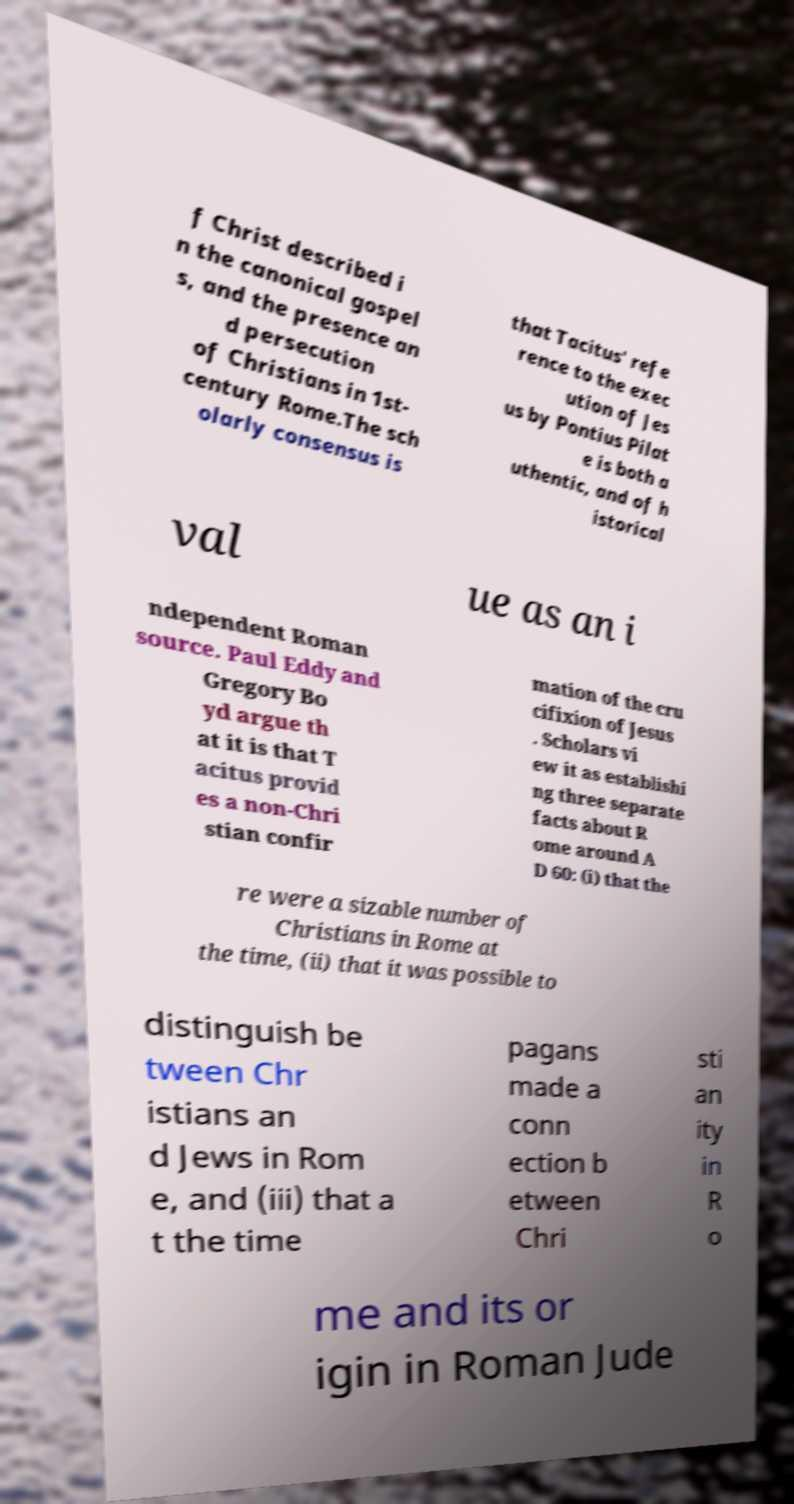There's text embedded in this image that I need extracted. Can you transcribe it verbatim? f Christ described i n the canonical gospel s, and the presence an d persecution of Christians in 1st- century Rome.The sch olarly consensus is that Tacitus' refe rence to the exec ution of Jes us by Pontius Pilat e is both a uthentic, and of h istorical val ue as an i ndependent Roman source. Paul Eddy and Gregory Bo yd argue th at it is that T acitus provid es a non-Chri stian confir mation of the cru cifixion of Jesus . Scholars vi ew it as establishi ng three separate facts about R ome around A D 60: (i) that the re were a sizable number of Christians in Rome at the time, (ii) that it was possible to distinguish be tween Chr istians an d Jews in Rom e, and (iii) that a t the time pagans made a conn ection b etween Chri sti an ity in R o me and its or igin in Roman Jude 